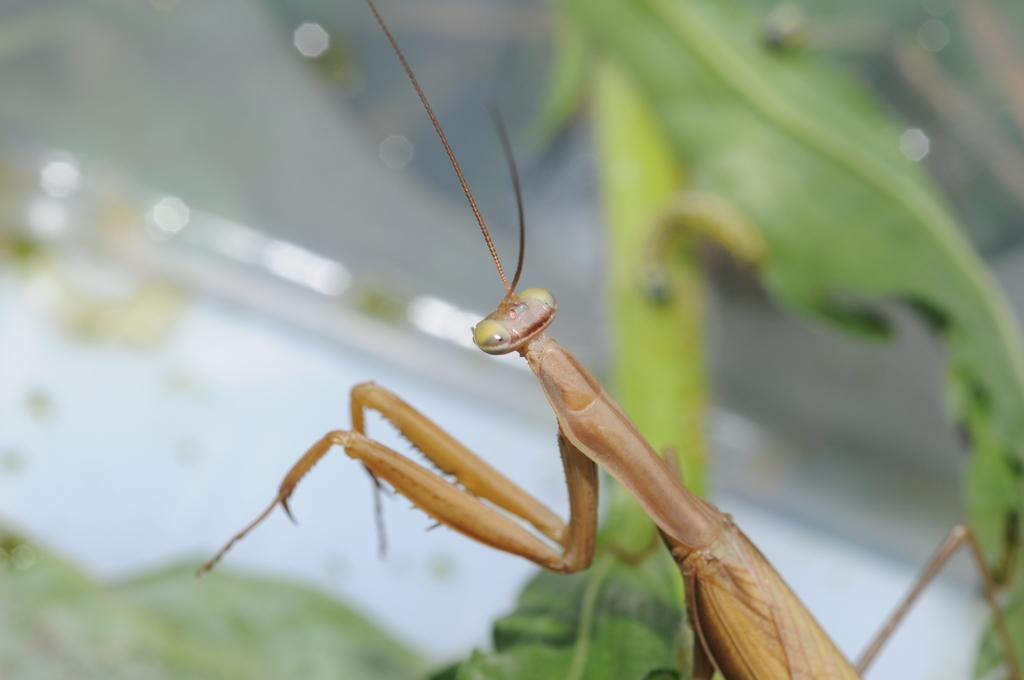What is the main subject of the image? There is a grasshopper in the center of the image. Can you describe the setting of the image? The image features a grasshopper in the main subject and a leaf in the background. Where is the downtown area in the image? There is no downtown area present in the image; it features a grasshopper and a leaf. What type of suit is the grasshopper wearing in the image? The grasshopper is not wearing a suit in the image; it is a grasshopper in its natural form. 